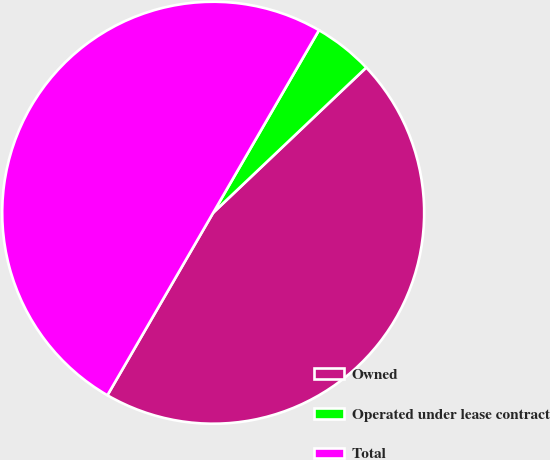Convert chart to OTSL. <chart><loc_0><loc_0><loc_500><loc_500><pie_chart><fcel>Owned<fcel>Operated under lease contract<fcel>Total<nl><fcel>45.44%<fcel>4.56%<fcel>50.0%<nl></chart> 